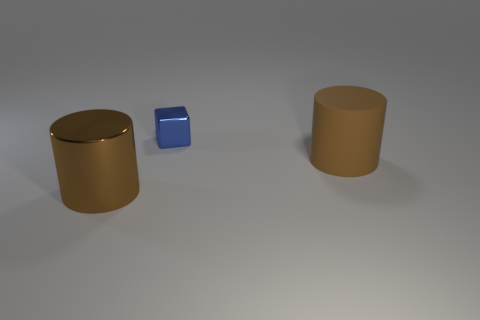Add 3 cylinders. How many objects exist? 6 Subtract all blocks. How many objects are left? 2 Subtract 0 gray cubes. How many objects are left? 3 Subtract all small metal cubes. Subtract all brown rubber cylinders. How many objects are left? 1 Add 3 brown objects. How many brown objects are left? 5 Add 2 blue objects. How many blue objects exist? 3 